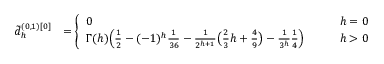<formula> <loc_0><loc_0><loc_500><loc_500>\begin{array} { r l } { \tilde { d } _ { h } ^ { ( 0 , 1 ) [ 0 ] } } & { = \left \{ \begin{array} { l l } { 0 } & { \quad h = 0 } \\ { \Gamma ( h ) \left ( \frac { 1 } { 2 } - ( - 1 ) ^ { h } \frac { 1 } 3 6 } - \frac { 1 } { 2 ^ { h + 1 } } \left ( \frac { 2 } { 3 } h + \frac { 4 } { 9 } \right ) - \frac { 1 } { 3 ^ { h } } \frac { 1 } { 4 } \right ) } & { \quad h > 0 } \end{array} } \end{array}</formula> 